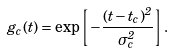<formula> <loc_0><loc_0><loc_500><loc_500>g _ { c } ( t ) = \exp \left [ - \frac { ( t - t _ { c } ) ^ { 2 } } { \sigma _ { c } ^ { 2 } } \right ] .</formula> 